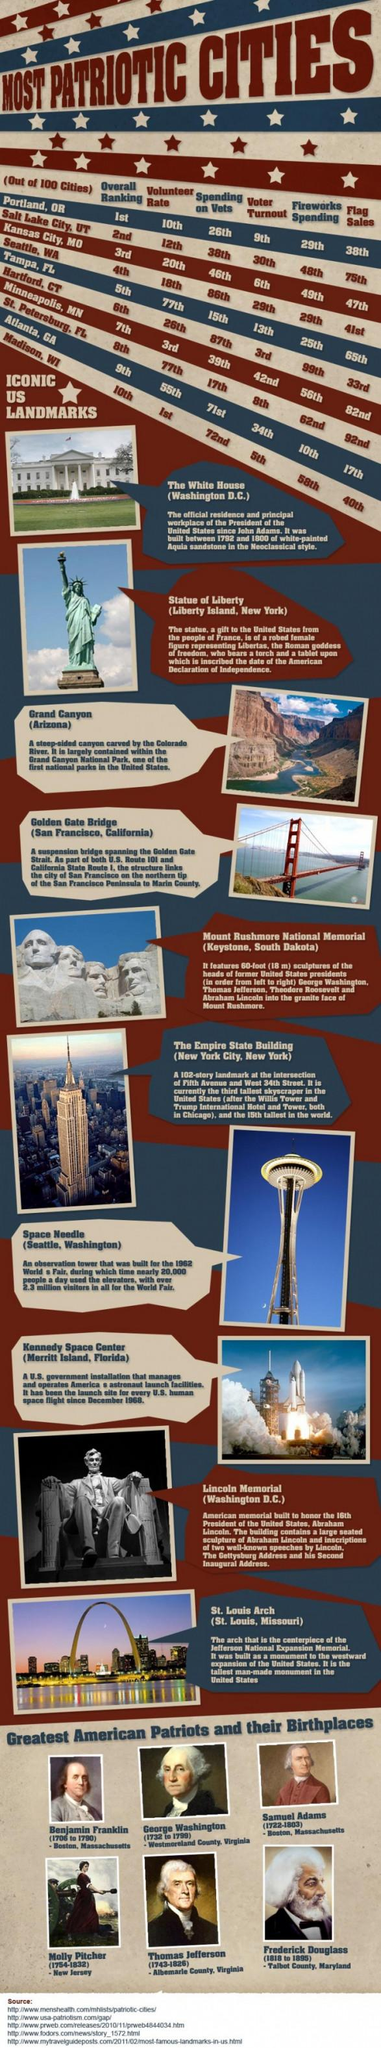Highlight a few significant elements in this photo. The third landmark is located in Arizona Out of the iconic US landmarks shown, 10 are present. The Lincoln Memorial is the second landmark from the bottom. According to voter turnout data, Hartford, Connecticut is ranked third. The number of sources provided is 5. 